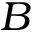<formula> <loc_0><loc_0><loc_500><loc_500>B</formula> 